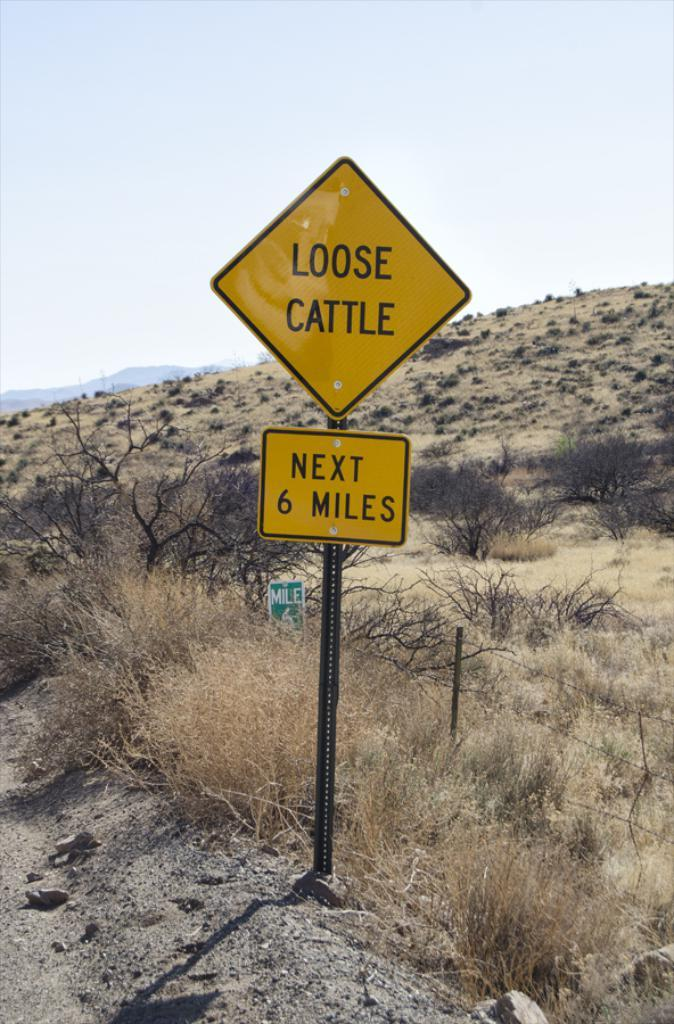What type of land is visible in the image? There is a land in the image. What object is present on the land? There is a pole in the image. How are the boards related to the pole? Boards are attached to the pole. What is written or depicted on the boards? There is text on the boards. What can be seen in the background of the image? There are plants, a hill, and the sky visible in the background of the image. How many fingers can be seen waving in the image? There are no fingers or waving gestures visible in the image. 